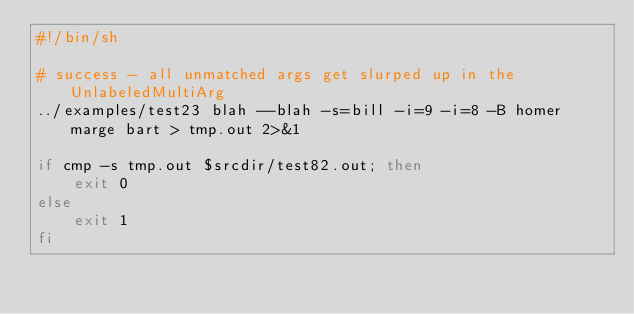<code> <loc_0><loc_0><loc_500><loc_500><_Bash_>#!/bin/sh

# success - all unmatched args get slurped up in the UnlabeledMultiArg
../examples/test23 blah --blah -s=bill -i=9 -i=8 -B homer marge bart > tmp.out 2>&1

if cmp -s tmp.out $srcdir/test82.out; then
	exit 0
else
	exit 1
fi

</code> 